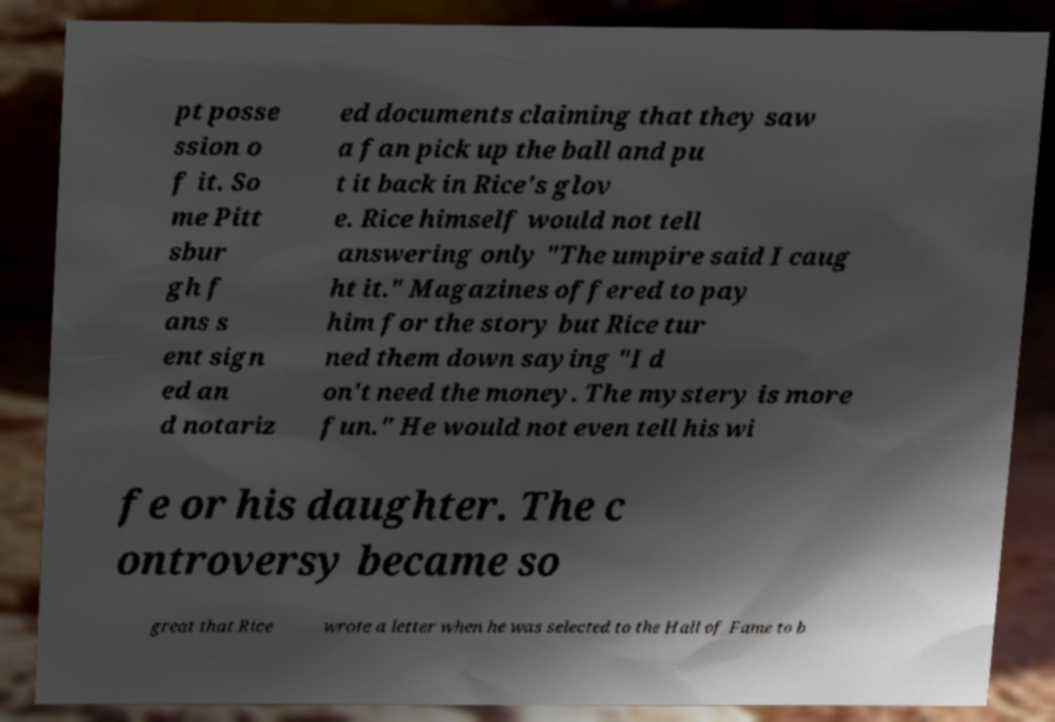Can you accurately transcribe the text from the provided image for me? pt posse ssion o f it. So me Pitt sbur gh f ans s ent sign ed an d notariz ed documents claiming that they saw a fan pick up the ball and pu t it back in Rice's glov e. Rice himself would not tell answering only "The umpire said I caug ht it." Magazines offered to pay him for the story but Rice tur ned them down saying "I d on't need the money. The mystery is more fun." He would not even tell his wi fe or his daughter. The c ontroversy became so great that Rice wrote a letter when he was selected to the Hall of Fame to b 